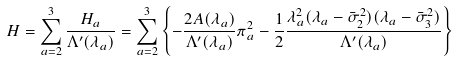<formula> <loc_0><loc_0><loc_500><loc_500>H = \sum _ { a = 2 } ^ { 3 } \frac { H _ { a } } { \Lambda ^ { \prime } ( \lambda _ { a } ) } = \sum _ { a = 2 } ^ { 3 } \left \{ - \frac { 2 A ( \lambda _ { a } ) } { \Lambda ^ { \prime } ( \lambda _ { a } ) } \pi _ { a } ^ { 2 } - \frac { 1 } { 2 } \frac { \lambda _ { a } ^ { 2 } ( \lambda _ { a } - \bar { \sigma } _ { 2 } ^ { 2 } ) ( \lambda _ { a } - \bar { \sigma } _ { 3 } ^ { 2 } ) } { \Lambda ^ { \prime } ( \lambda _ { a } ) } \right \}</formula> 